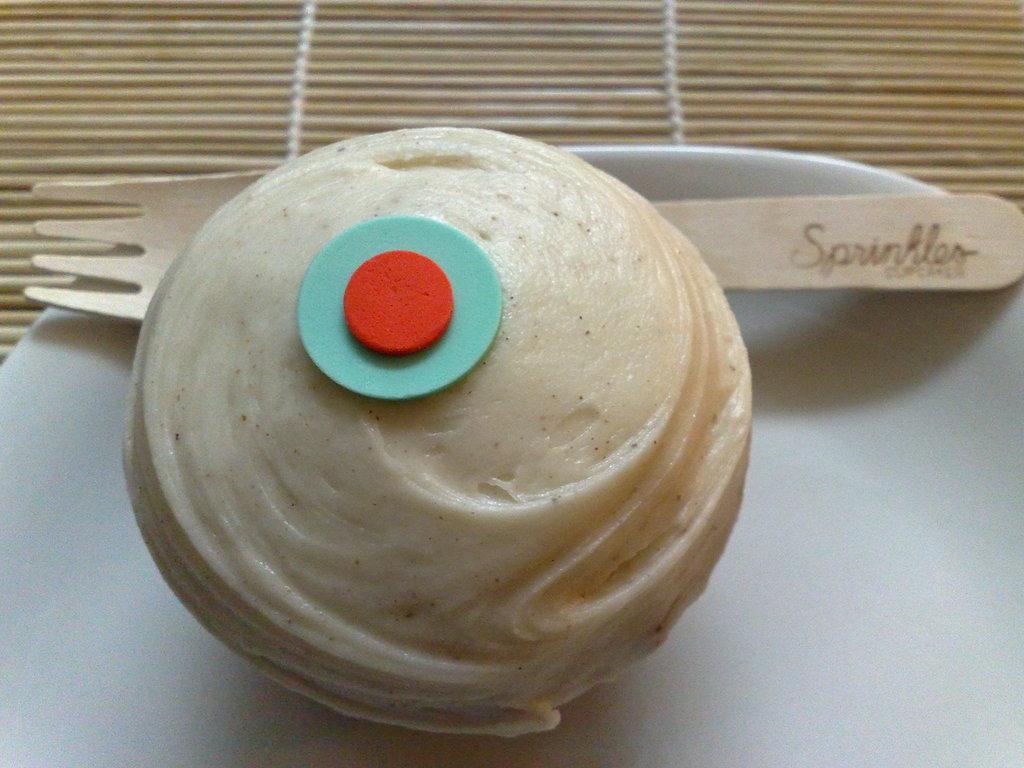Please provide a concise description of this image. In this image there is food, there is a spoon, there is a plate on the surface. 